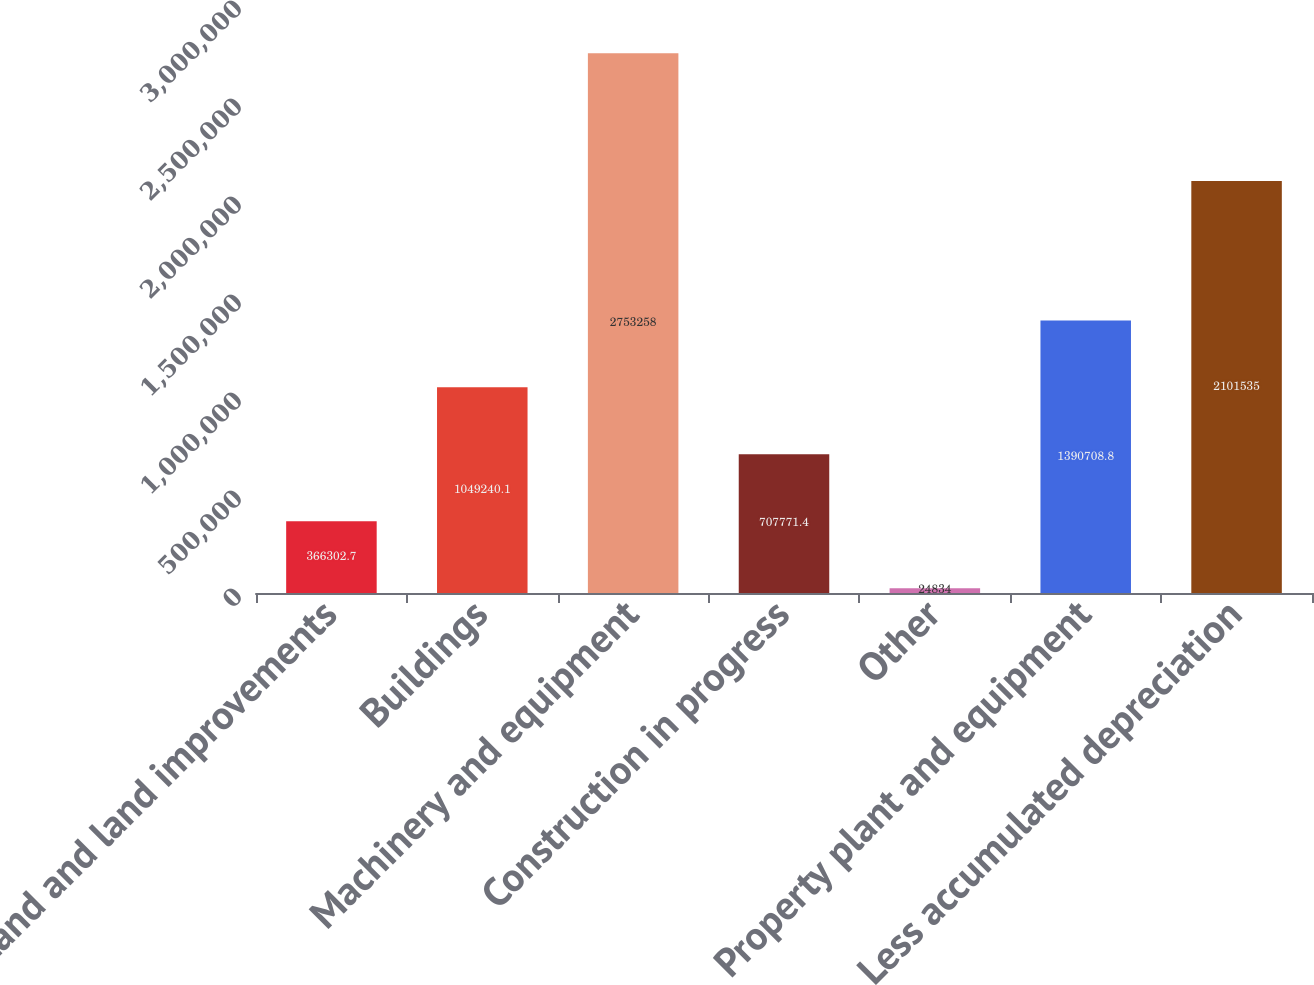<chart> <loc_0><loc_0><loc_500><loc_500><bar_chart><fcel>Land and land improvements<fcel>Buildings<fcel>Machinery and equipment<fcel>Construction in progress<fcel>Other<fcel>Property plant and equipment<fcel>Less accumulated depreciation<nl><fcel>366303<fcel>1.04924e+06<fcel>2.75326e+06<fcel>707771<fcel>24834<fcel>1.39071e+06<fcel>2.10154e+06<nl></chart> 